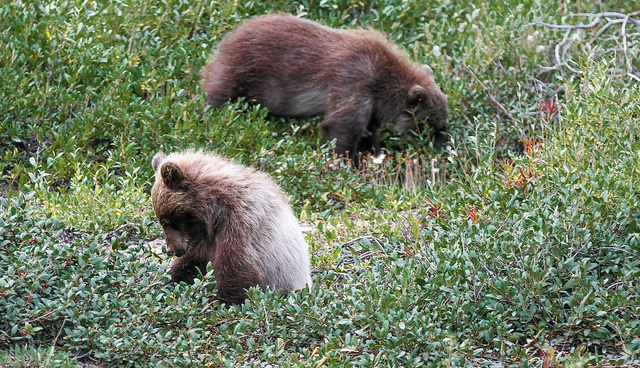Describe the objects in this image and their specific colors. I can see bear in olive, gray, and black tones and bear in olive, lightgray, black, gray, and darkgray tones in this image. 